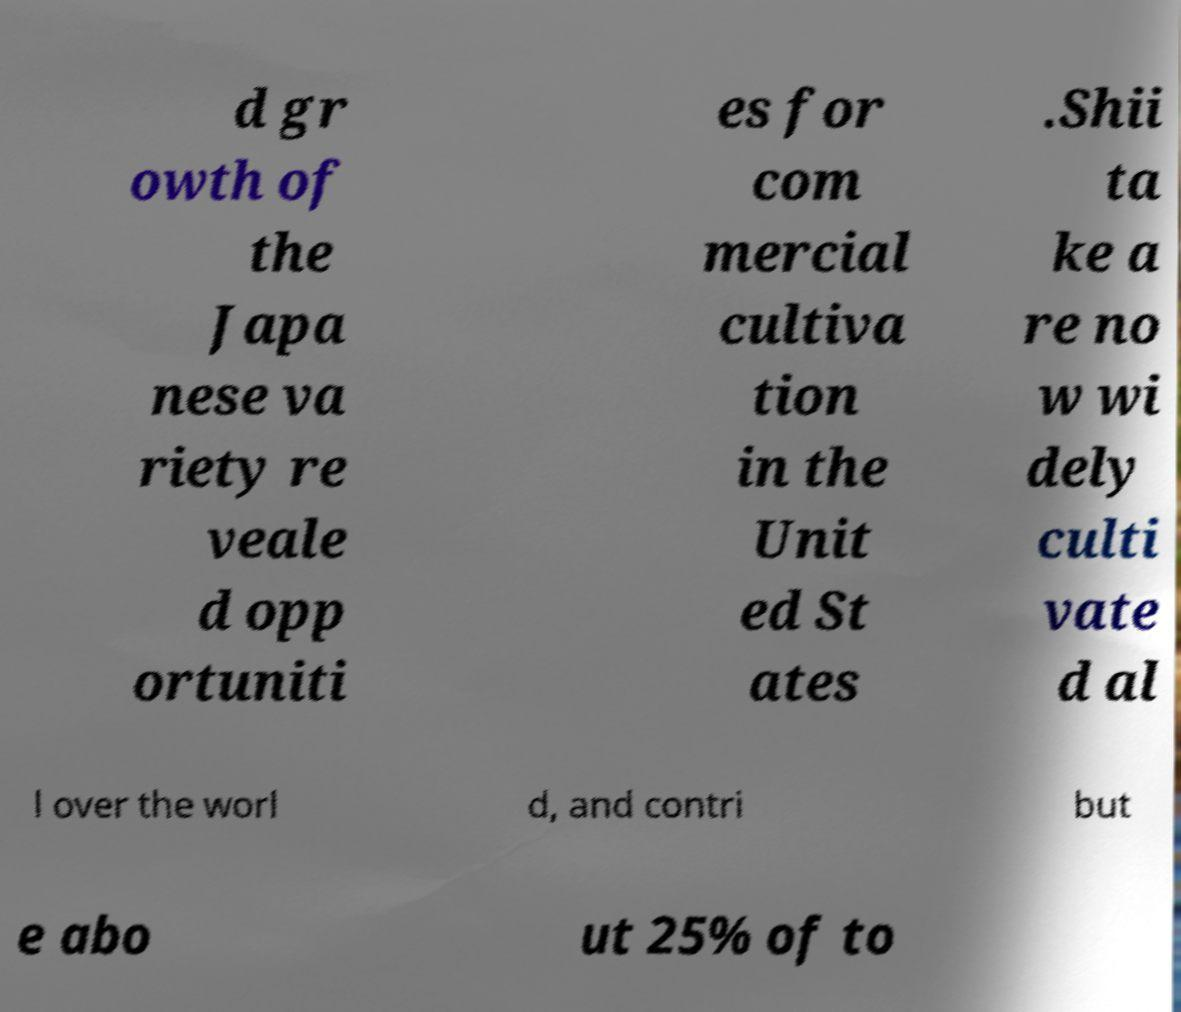What messages or text are displayed in this image? I need them in a readable, typed format. d gr owth of the Japa nese va riety re veale d opp ortuniti es for com mercial cultiva tion in the Unit ed St ates .Shii ta ke a re no w wi dely culti vate d al l over the worl d, and contri but e abo ut 25% of to 